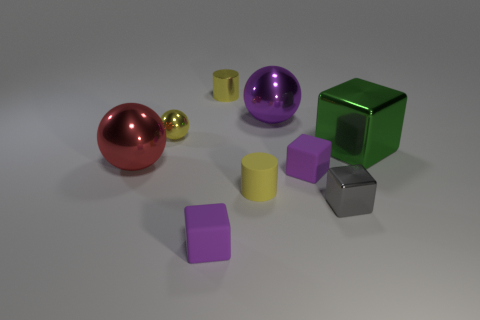Subtract all gray blocks. How many blocks are left? 3 Subtract all big green cubes. How many cubes are left? 3 Subtract all yellow cubes. Subtract all green cylinders. How many cubes are left? 4 Add 1 small cylinders. How many objects exist? 10 Subtract all cylinders. How many objects are left? 7 Add 7 red objects. How many red objects exist? 8 Subtract 0 brown cylinders. How many objects are left? 9 Subtract all tiny gray things. Subtract all purple shiny balls. How many objects are left? 7 Add 8 green shiny things. How many green shiny things are left? 9 